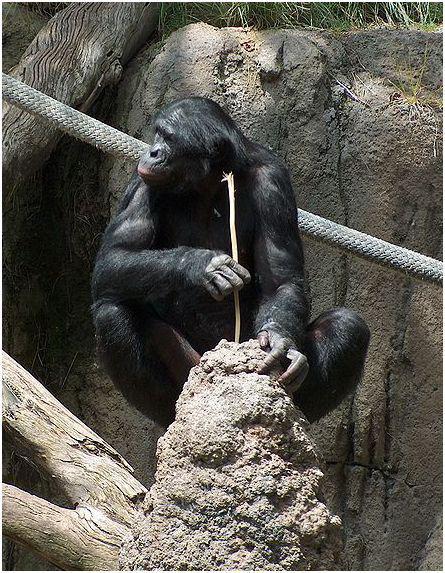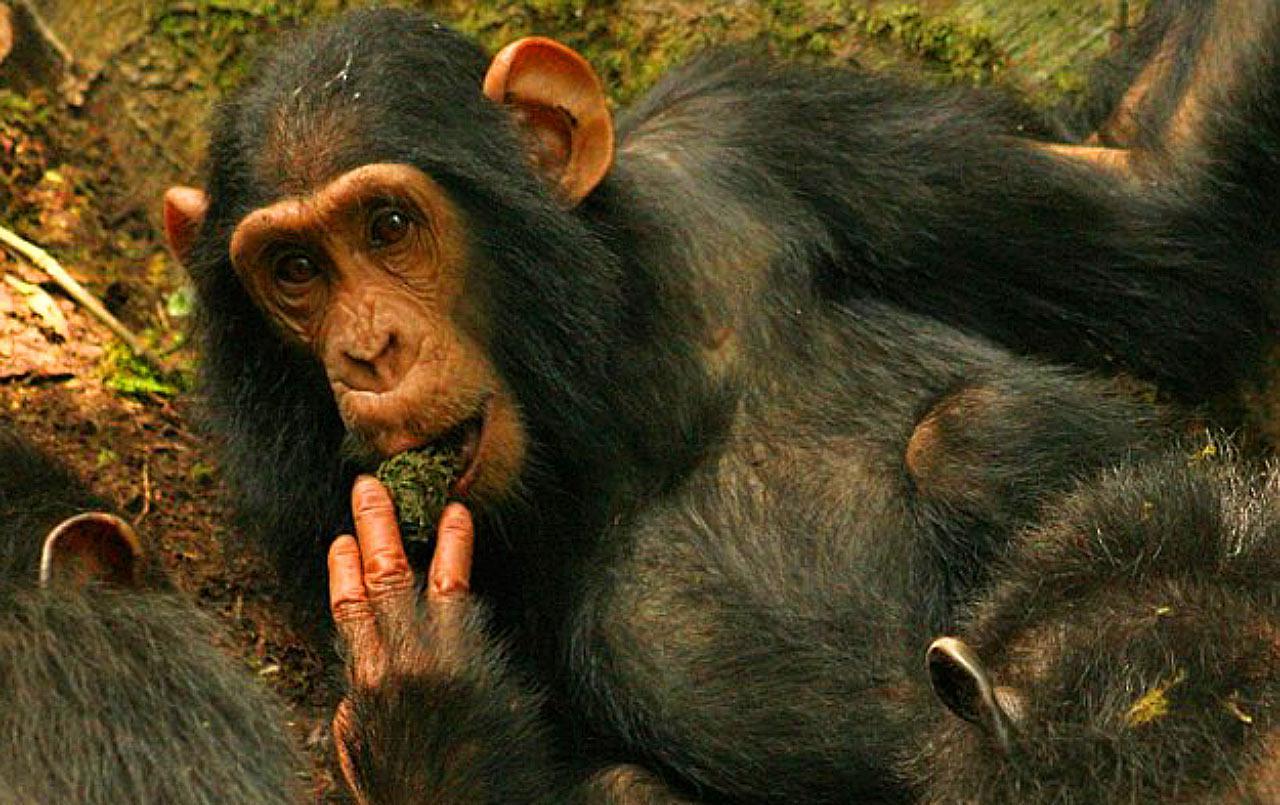The first image is the image on the left, the second image is the image on the right. Given the left and right images, does the statement "One image shows a close-mouthed chimp holding a stick and poking it down at something." hold true? Answer yes or no. Yes. The first image is the image on the left, the second image is the image on the right. For the images displayed, is the sentence "There are more animals in the image on the left." factually correct? Answer yes or no. No. 